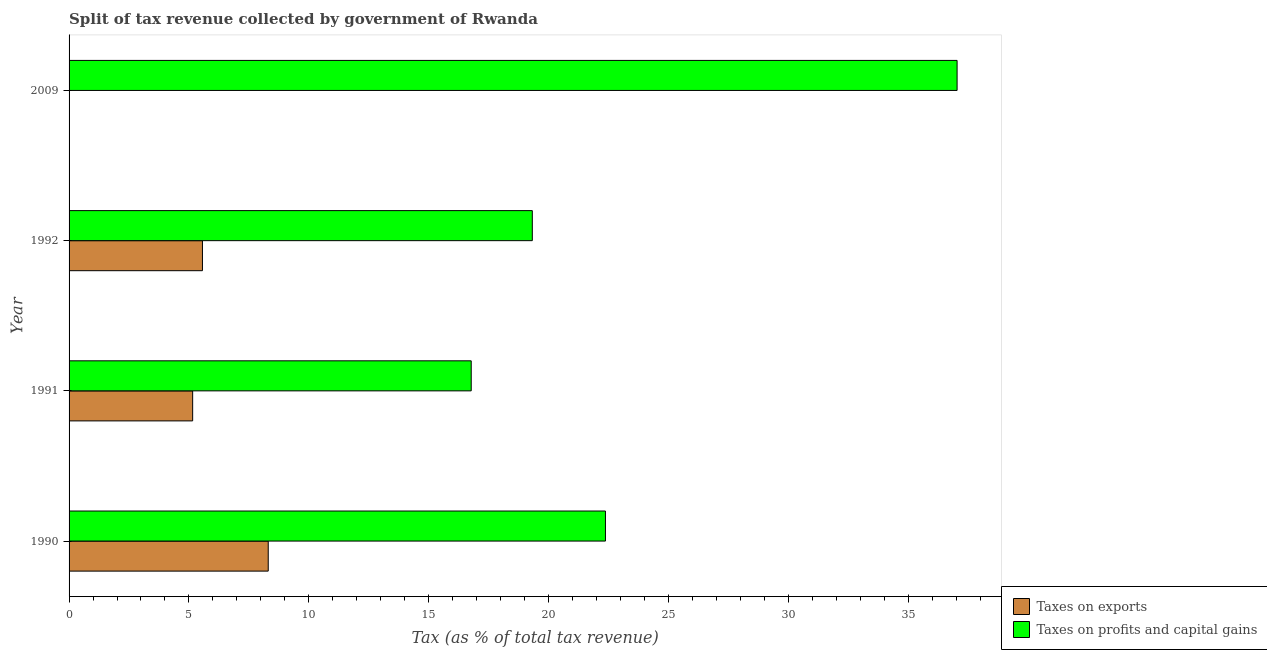How many different coloured bars are there?
Your response must be concise. 2. Are the number of bars per tick equal to the number of legend labels?
Your response must be concise. Yes. How many bars are there on the 2nd tick from the top?
Ensure brevity in your answer.  2. How many bars are there on the 2nd tick from the bottom?
Make the answer very short. 2. What is the label of the 4th group of bars from the top?
Make the answer very short. 1990. What is the percentage of revenue obtained from taxes on exports in 2009?
Your answer should be very brief. 0. Across all years, what is the maximum percentage of revenue obtained from taxes on exports?
Keep it short and to the point. 8.31. Across all years, what is the minimum percentage of revenue obtained from taxes on exports?
Your response must be concise. 0. In which year was the percentage of revenue obtained from taxes on profits and capital gains minimum?
Keep it short and to the point. 1991. What is the total percentage of revenue obtained from taxes on profits and capital gains in the graph?
Offer a terse response. 95.52. What is the difference between the percentage of revenue obtained from taxes on profits and capital gains in 1992 and that in 2009?
Offer a terse response. -17.72. What is the difference between the percentage of revenue obtained from taxes on exports in 1990 and the percentage of revenue obtained from taxes on profits and capital gains in 2009?
Provide a short and direct response. -28.74. What is the average percentage of revenue obtained from taxes on exports per year?
Ensure brevity in your answer.  4.76. In the year 2009, what is the difference between the percentage of revenue obtained from taxes on exports and percentage of revenue obtained from taxes on profits and capital gains?
Offer a terse response. -37.04. In how many years, is the percentage of revenue obtained from taxes on profits and capital gains greater than 23 %?
Provide a succinct answer. 1. What is the ratio of the percentage of revenue obtained from taxes on profits and capital gains in 1990 to that in 1991?
Your answer should be compact. 1.33. Is the difference between the percentage of revenue obtained from taxes on profits and capital gains in 1990 and 2009 greater than the difference between the percentage of revenue obtained from taxes on exports in 1990 and 2009?
Your answer should be very brief. No. What is the difference between the highest and the second highest percentage of revenue obtained from taxes on exports?
Your answer should be very brief. 2.74. What is the difference between the highest and the lowest percentage of revenue obtained from taxes on profits and capital gains?
Offer a very short reply. 20.27. What does the 2nd bar from the top in 1992 represents?
Make the answer very short. Taxes on exports. What does the 2nd bar from the bottom in 1992 represents?
Offer a very short reply. Taxes on profits and capital gains. Are all the bars in the graph horizontal?
Provide a succinct answer. Yes. How many years are there in the graph?
Provide a short and direct response. 4. Are the values on the major ticks of X-axis written in scientific E-notation?
Keep it short and to the point. No. Does the graph contain any zero values?
Make the answer very short. No. Does the graph contain grids?
Offer a very short reply. No. How many legend labels are there?
Keep it short and to the point. 2. How are the legend labels stacked?
Make the answer very short. Vertical. What is the title of the graph?
Keep it short and to the point. Split of tax revenue collected by government of Rwanda. Does "Birth rate" appear as one of the legend labels in the graph?
Offer a terse response. No. What is the label or title of the X-axis?
Provide a short and direct response. Tax (as % of total tax revenue). What is the label or title of the Y-axis?
Your response must be concise. Year. What is the Tax (as % of total tax revenue) in Taxes on exports in 1990?
Provide a short and direct response. 8.31. What is the Tax (as % of total tax revenue) of Taxes on profits and capital gains in 1990?
Provide a succinct answer. 22.38. What is the Tax (as % of total tax revenue) of Taxes on exports in 1991?
Make the answer very short. 5.16. What is the Tax (as % of total tax revenue) of Taxes on profits and capital gains in 1991?
Keep it short and to the point. 16.78. What is the Tax (as % of total tax revenue) in Taxes on exports in 1992?
Provide a succinct answer. 5.56. What is the Tax (as % of total tax revenue) of Taxes on profits and capital gains in 1992?
Ensure brevity in your answer.  19.32. What is the Tax (as % of total tax revenue) in Taxes on exports in 2009?
Ensure brevity in your answer.  0. What is the Tax (as % of total tax revenue) of Taxes on profits and capital gains in 2009?
Offer a terse response. 37.04. Across all years, what is the maximum Tax (as % of total tax revenue) of Taxes on exports?
Make the answer very short. 8.31. Across all years, what is the maximum Tax (as % of total tax revenue) of Taxes on profits and capital gains?
Your answer should be compact. 37.04. Across all years, what is the minimum Tax (as % of total tax revenue) in Taxes on exports?
Offer a very short reply. 0. Across all years, what is the minimum Tax (as % of total tax revenue) in Taxes on profits and capital gains?
Provide a short and direct response. 16.78. What is the total Tax (as % of total tax revenue) of Taxes on exports in the graph?
Provide a succinct answer. 19.03. What is the total Tax (as % of total tax revenue) of Taxes on profits and capital gains in the graph?
Keep it short and to the point. 95.52. What is the difference between the Tax (as % of total tax revenue) of Taxes on exports in 1990 and that in 1991?
Your response must be concise. 3.15. What is the difference between the Tax (as % of total tax revenue) in Taxes on profits and capital gains in 1990 and that in 1991?
Your answer should be very brief. 5.6. What is the difference between the Tax (as % of total tax revenue) in Taxes on exports in 1990 and that in 1992?
Your answer should be very brief. 2.74. What is the difference between the Tax (as % of total tax revenue) of Taxes on profits and capital gains in 1990 and that in 1992?
Your response must be concise. 3.05. What is the difference between the Tax (as % of total tax revenue) in Taxes on exports in 1990 and that in 2009?
Offer a terse response. 8.3. What is the difference between the Tax (as % of total tax revenue) of Taxes on profits and capital gains in 1990 and that in 2009?
Offer a terse response. -14.67. What is the difference between the Tax (as % of total tax revenue) of Taxes on exports in 1991 and that in 1992?
Your answer should be compact. -0.41. What is the difference between the Tax (as % of total tax revenue) in Taxes on profits and capital gains in 1991 and that in 1992?
Provide a short and direct response. -2.55. What is the difference between the Tax (as % of total tax revenue) of Taxes on exports in 1991 and that in 2009?
Your answer should be very brief. 5.15. What is the difference between the Tax (as % of total tax revenue) in Taxes on profits and capital gains in 1991 and that in 2009?
Provide a succinct answer. -20.27. What is the difference between the Tax (as % of total tax revenue) of Taxes on exports in 1992 and that in 2009?
Ensure brevity in your answer.  5.56. What is the difference between the Tax (as % of total tax revenue) of Taxes on profits and capital gains in 1992 and that in 2009?
Offer a terse response. -17.72. What is the difference between the Tax (as % of total tax revenue) in Taxes on exports in 1990 and the Tax (as % of total tax revenue) in Taxes on profits and capital gains in 1991?
Provide a short and direct response. -8.47. What is the difference between the Tax (as % of total tax revenue) in Taxes on exports in 1990 and the Tax (as % of total tax revenue) in Taxes on profits and capital gains in 1992?
Give a very brief answer. -11.02. What is the difference between the Tax (as % of total tax revenue) in Taxes on exports in 1990 and the Tax (as % of total tax revenue) in Taxes on profits and capital gains in 2009?
Your answer should be compact. -28.74. What is the difference between the Tax (as % of total tax revenue) of Taxes on exports in 1991 and the Tax (as % of total tax revenue) of Taxes on profits and capital gains in 1992?
Give a very brief answer. -14.17. What is the difference between the Tax (as % of total tax revenue) of Taxes on exports in 1991 and the Tax (as % of total tax revenue) of Taxes on profits and capital gains in 2009?
Offer a terse response. -31.89. What is the difference between the Tax (as % of total tax revenue) of Taxes on exports in 1992 and the Tax (as % of total tax revenue) of Taxes on profits and capital gains in 2009?
Give a very brief answer. -31.48. What is the average Tax (as % of total tax revenue) of Taxes on exports per year?
Your answer should be very brief. 4.76. What is the average Tax (as % of total tax revenue) of Taxes on profits and capital gains per year?
Your answer should be very brief. 23.88. In the year 1990, what is the difference between the Tax (as % of total tax revenue) of Taxes on exports and Tax (as % of total tax revenue) of Taxes on profits and capital gains?
Keep it short and to the point. -14.07. In the year 1991, what is the difference between the Tax (as % of total tax revenue) of Taxes on exports and Tax (as % of total tax revenue) of Taxes on profits and capital gains?
Keep it short and to the point. -11.62. In the year 1992, what is the difference between the Tax (as % of total tax revenue) of Taxes on exports and Tax (as % of total tax revenue) of Taxes on profits and capital gains?
Your answer should be very brief. -13.76. In the year 2009, what is the difference between the Tax (as % of total tax revenue) in Taxes on exports and Tax (as % of total tax revenue) in Taxes on profits and capital gains?
Ensure brevity in your answer.  -37.04. What is the ratio of the Tax (as % of total tax revenue) in Taxes on exports in 1990 to that in 1991?
Your answer should be very brief. 1.61. What is the ratio of the Tax (as % of total tax revenue) of Taxes on profits and capital gains in 1990 to that in 1991?
Keep it short and to the point. 1.33. What is the ratio of the Tax (as % of total tax revenue) in Taxes on exports in 1990 to that in 1992?
Ensure brevity in your answer.  1.49. What is the ratio of the Tax (as % of total tax revenue) in Taxes on profits and capital gains in 1990 to that in 1992?
Provide a succinct answer. 1.16. What is the ratio of the Tax (as % of total tax revenue) of Taxes on exports in 1990 to that in 2009?
Your answer should be very brief. 1754.5. What is the ratio of the Tax (as % of total tax revenue) in Taxes on profits and capital gains in 1990 to that in 2009?
Keep it short and to the point. 0.6. What is the ratio of the Tax (as % of total tax revenue) of Taxes on exports in 1991 to that in 1992?
Give a very brief answer. 0.93. What is the ratio of the Tax (as % of total tax revenue) of Taxes on profits and capital gains in 1991 to that in 1992?
Ensure brevity in your answer.  0.87. What is the ratio of the Tax (as % of total tax revenue) of Taxes on exports in 1991 to that in 2009?
Your answer should be very brief. 1088.75. What is the ratio of the Tax (as % of total tax revenue) of Taxes on profits and capital gains in 1991 to that in 2009?
Make the answer very short. 0.45. What is the ratio of the Tax (as % of total tax revenue) in Taxes on exports in 1992 to that in 2009?
Give a very brief answer. 1175.04. What is the ratio of the Tax (as % of total tax revenue) in Taxes on profits and capital gains in 1992 to that in 2009?
Offer a terse response. 0.52. What is the difference between the highest and the second highest Tax (as % of total tax revenue) in Taxes on exports?
Your answer should be compact. 2.74. What is the difference between the highest and the second highest Tax (as % of total tax revenue) in Taxes on profits and capital gains?
Ensure brevity in your answer.  14.67. What is the difference between the highest and the lowest Tax (as % of total tax revenue) in Taxes on exports?
Your answer should be very brief. 8.3. What is the difference between the highest and the lowest Tax (as % of total tax revenue) in Taxes on profits and capital gains?
Your response must be concise. 20.27. 